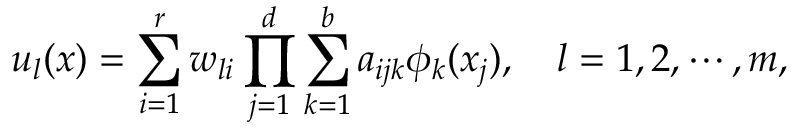<formula> <loc_0><loc_0><loc_500><loc_500>u _ { l } ( x ) = \sum _ { i = 1 } ^ { r } w _ { l i } \prod _ { j = 1 } ^ { d } \sum _ { k = 1 } ^ { b } a _ { i j k } \phi _ { k } ( x _ { j } ) , \quad l = 1 , 2 , \cdots , m ,</formula> 